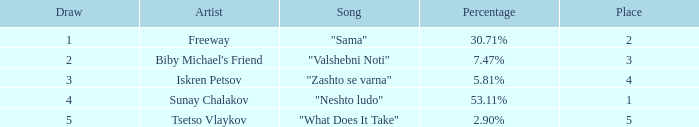What is the maximum draw when the position is below 3 and the proportion is 3 1.0. 